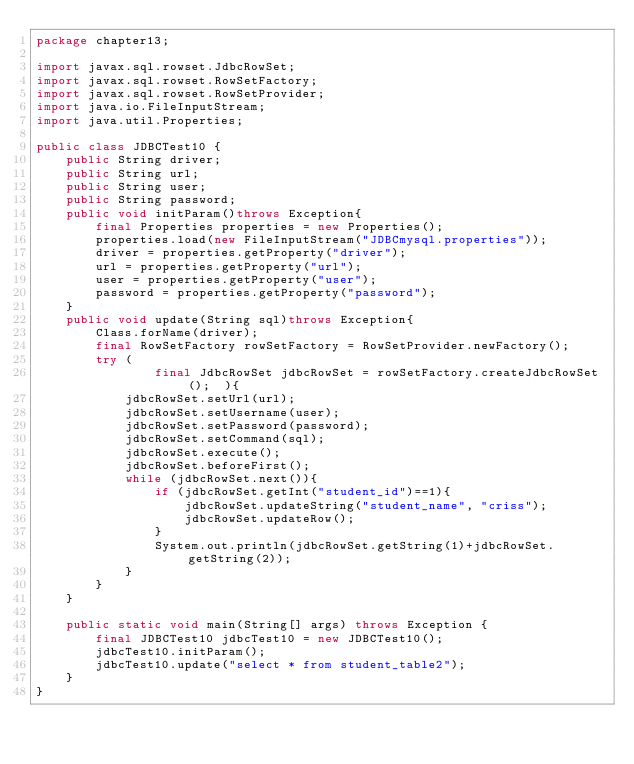<code> <loc_0><loc_0><loc_500><loc_500><_Java_>package chapter13;

import javax.sql.rowset.JdbcRowSet;
import javax.sql.rowset.RowSetFactory;
import javax.sql.rowset.RowSetProvider;
import java.io.FileInputStream;
import java.util.Properties;

public class JDBCTest10 {
    public String driver;
    public String url;
    public String user;
    public String password;
    public void initParam()throws Exception{
        final Properties properties = new Properties();
        properties.load(new FileInputStream("JDBCmysql.properties"));
        driver = properties.getProperty("driver");
        url = properties.getProperty("url");
        user = properties.getProperty("user");
        password = properties.getProperty("password");
    }
    public void update(String sql)throws Exception{
        Class.forName(driver);
        final RowSetFactory rowSetFactory = RowSetProvider.newFactory();
        try (
                final JdbcRowSet jdbcRowSet = rowSetFactory.createJdbcRowSet();  ){
            jdbcRowSet.setUrl(url);
            jdbcRowSet.setUsername(user);
            jdbcRowSet.setPassword(password);
            jdbcRowSet.setCommand(sql);
            jdbcRowSet.execute();
            jdbcRowSet.beforeFirst();
            while (jdbcRowSet.next()){
                if (jdbcRowSet.getInt("student_id")==1){
                    jdbcRowSet.updateString("student_name", "criss");
                    jdbcRowSet.updateRow();
                }
                System.out.println(jdbcRowSet.getString(1)+jdbcRowSet.getString(2));
            }
        }
    }

    public static void main(String[] args) throws Exception {
        final JDBCTest10 jdbcTest10 = new JDBCTest10();
        jdbcTest10.initParam();
        jdbcTest10.update("select * from student_table2");
    }
}
</code> 